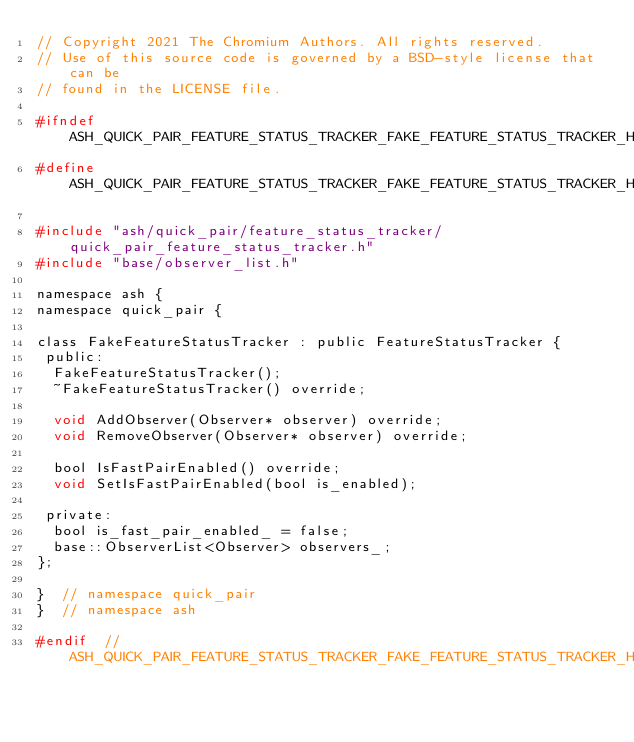<code> <loc_0><loc_0><loc_500><loc_500><_C_>// Copyright 2021 The Chromium Authors. All rights reserved.
// Use of this source code is governed by a BSD-style license that can be
// found in the LICENSE file.

#ifndef ASH_QUICK_PAIR_FEATURE_STATUS_TRACKER_FAKE_FEATURE_STATUS_TRACKER_H_
#define ASH_QUICK_PAIR_FEATURE_STATUS_TRACKER_FAKE_FEATURE_STATUS_TRACKER_H_

#include "ash/quick_pair/feature_status_tracker/quick_pair_feature_status_tracker.h"
#include "base/observer_list.h"

namespace ash {
namespace quick_pair {

class FakeFeatureStatusTracker : public FeatureStatusTracker {
 public:
  FakeFeatureStatusTracker();
  ~FakeFeatureStatusTracker() override;

  void AddObserver(Observer* observer) override;
  void RemoveObserver(Observer* observer) override;

  bool IsFastPairEnabled() override;
  void SetIsFastPairEnabled(bool is_enabled);

 private:
  bool is_fast_pair_enabled_ = false;
  base::ObserverList<Observer> observers_;
};

}  // namespace quick_pair
}  // namespace ash

#endif  // ASH_QUICK_PAIR_FEATURE_STATUS_TRACKER_FAKE_FEATURE_STATUS_TRACKER_H_
</code> 